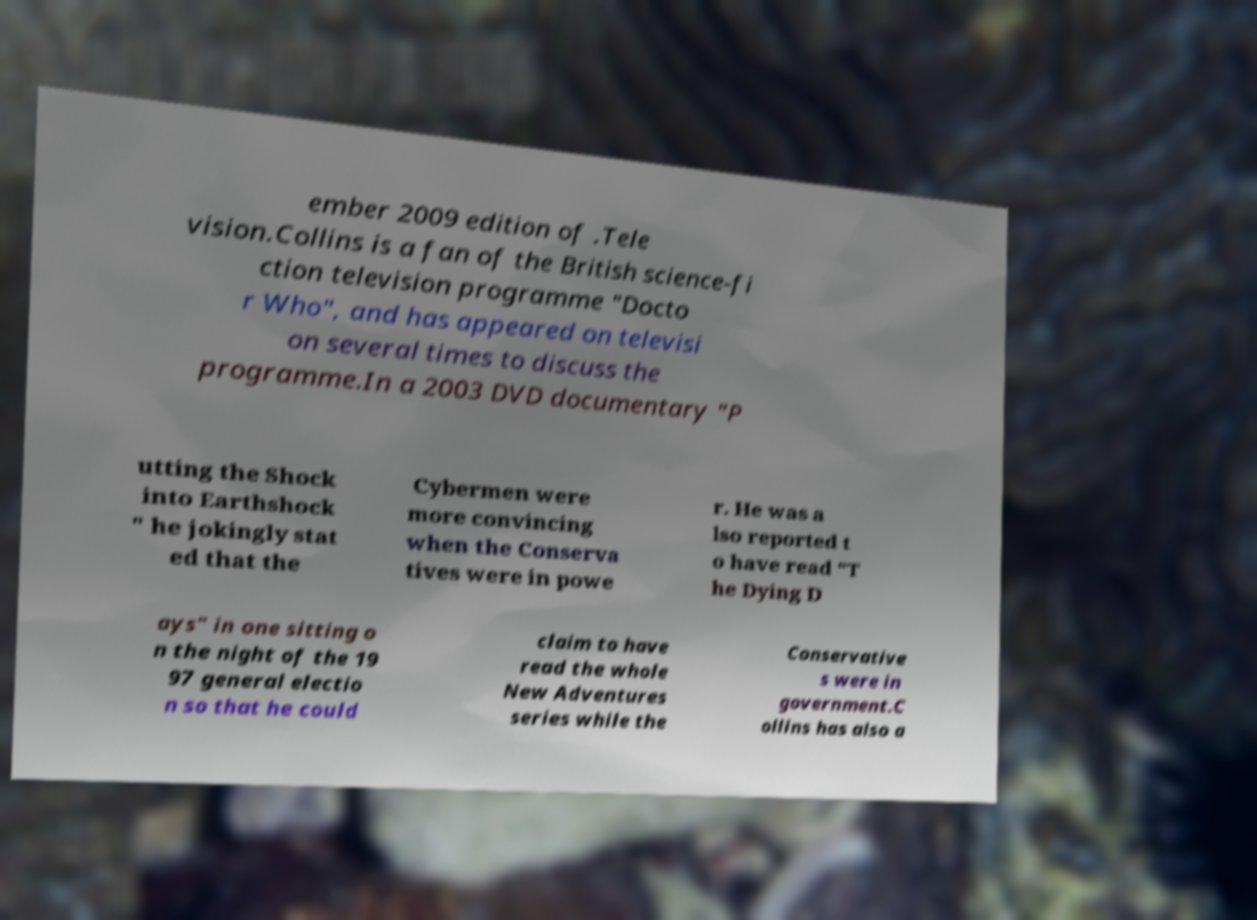Please read and relay the text visible in this image. What does it say? ember 2009 edition of .Tele vision.Collins is a fan of the British science-fi ction television programme "Docto r Who", and has appeared on televisi on several times to discuss the programme.In a 2003 DVD documentary "P utting the Shock into Earthshock " he jokingly stat ed that the Cybermen were more convincing when the Conserva tives were in powe r. He was a lso reported t o have read "T he Dying D ays" in one sitting o n the night of the 19 97 general electio n so that he could claim to have read the whole New Adventures series while the Conservative s were in government.C ollins has also a 